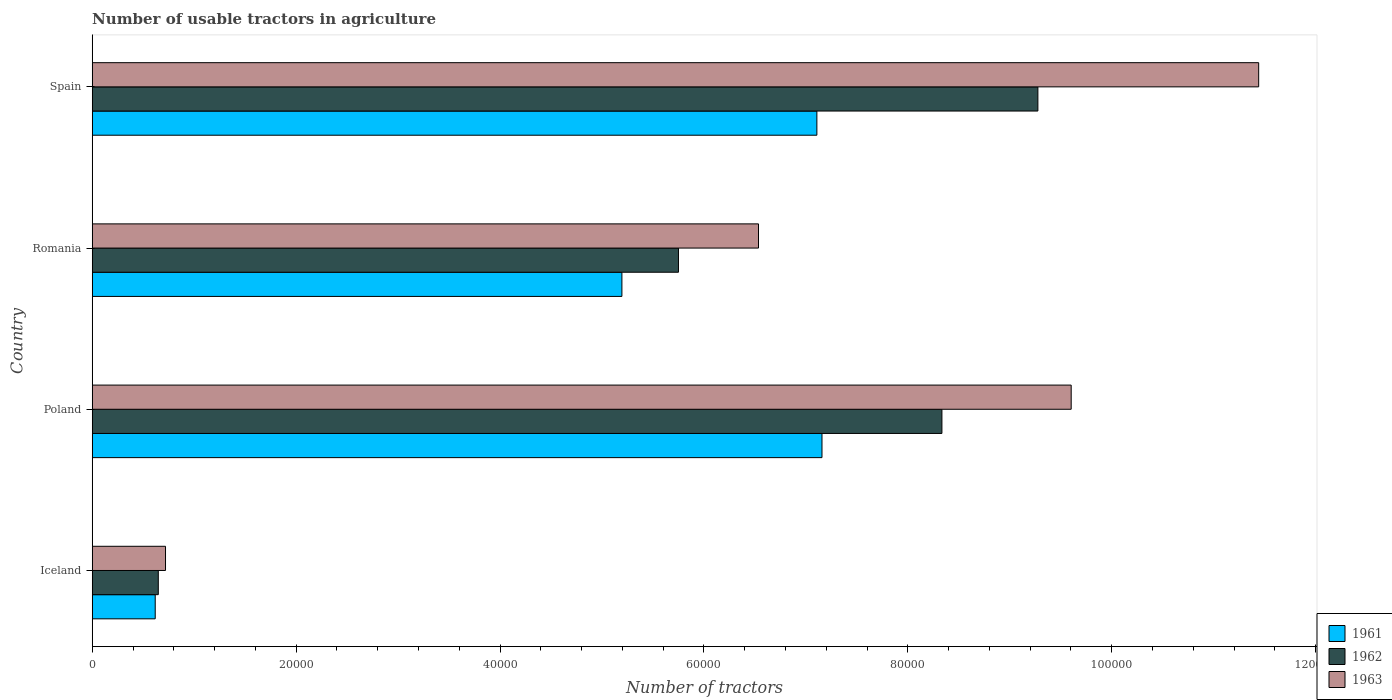What is the label of the 4th group of bars from the top?
Make the answer very short. Iceland. What is the number of usable tractors in agriculture in 1962 in Poland?
Your response must be concise. 8.33e+04. Across all countries, what is the maximum number of usable tractors in agriculture in 1962?
Ensure brevity in your answer.  9.28e+04. Across all countries, what is the minimum number of usable tractors in agriculture in 1962?
Keep it short and to the point. 6479. What is the total number of usable tractors in agriculture in 1963 in the graph?
Offer a very short reply. 2.83e+05. What is the difference between the number of usable tractors in agriculture in 1963 in Poland and that in Spain?
Your response must be concise. -1.84e+04. What is the difference between the number of usable tractors in agriculture in 1963 in Romania and the number of usable tractors in agriculture in 1962 in Spain?
Your answer should be very brief. -2.74e+04. What is the average number of usable tractors in agriculture in 1962 per country?
Make the answer very short. 6.00e+04. What is the difference between the number of usable tractors in agriculture in 1962 and number of usable tractors in agriculture in 1963 in Spain?
Keep it short and to the point. -2.17e+04. In how many countries, is the number of usable tractors in agriculture in 1961 greater than 116000 ?
Your response must be concise. 0. What is the ratio of the number of usable tractors in agriculture in 1961 in Poland to that in Spain?
Your response must be concise. 1.01. Is the number of usable tractors in agriculture in 1961 in Iceland less than that in Spain?
Provide a short and direct response. Yes. What is the difference between the highest and the lowest number of usable tractors in agriculture in 1962?
Your answer should be very brief. 8.63e+04. Is the sum of the number of usable tractors in agriculture in 1962 in Poland and Romania greater than the maximum number of usable tractors in agriculture in 1961 across all countries?
Provide a succinct answer. Yes. Is it the case that in every country, the sum of the number of usable tractors in agriculture in 1963 and number of usable tractors in agriculture in 1962 is greater than the number of usable tractors in agriculture in 1961?
Provide a short and direct response. Yes. Are all the bars in the graph horizontal?
Give a very brief answer. Yes. How many countries are there in the graph?
Offer a terse response. 4. What is the difference between two consecutive major ticks on the X-axis?
Keep it short and to the point. 2.00e+04. Where does the legend appear in the graph?
Ensure brevity in your answer.  Bottom right. How many legend labels are there?
Make the answer very short. 3. How are the legend labels stacked?
Your answer should be compact. Vertical. What is the title of the graph?
Provide a succinct answer. Number of usable tractors in agriculture. What is the label or title of the X-axis?
Provide a succinct answer. Number of tractors. What is the label or title of the Y-axis?
Provide a succinct answer. Country. What is the Number of tractors of 1961 in Iceland?
Ensure brevity in your answer.  6177. What is the Number of tractors of 1962 in Iceland?
Keep it short and to the point. 6479. What is the Number of tractors of 1963 in Iceland?
Your response must be concise. 7187. What is the Number of tractors in 1961 in Poland?
Keep it short and to the point. 7.16e+04. What is the Number of tractors in 1962 in Poland?
Make the answer very short. 8.33e+04. What is the Number of tractors of 1963 in Poland?
Provide a succinct answer. 9.60e+04. What is the Number of tractors in 1961 in Romania?
Keep it short and to the point. 5.20e+04. What is the Number of tractors in 1962 in Romania?
Offer a terse response. 5.75e+04. What is the Number of tractors of 1963 in Romania?
Provide a succinct answer. 6.54e+04. What is the Number of tractors in 1961 in Spain?
Your response must be concise. 7.11e+04. What is the Number of tractors of 1962 in Spain?
Keep it short and to the point. 9.28e+04. What is the Number of tractors in 1963 in Spain?
Give a very brief answer. 1.14e+05. Across all countries, what is the maximum Number of tractors of 1961?
Provide a succinct answer. 7.16e+04. Across all countries, what is the maximum Number of tractors of 1962?
Provide a short and direct response. 9.28e+04. Across all countries, what is the maximum Number of tractors in 1963?
Ensure brevity in your answer.  1.14e+05. Across all countries, what is the minimum Number of tractors in 1961?
Your answer should be very brief. 6177. Across all countries, what is the minimum Number of tractors in 1962?
Offer a terse response. 6479. Across all countries, what is the minimum Number of tractors of 1963?
Offer a terse response. 7187. What is the total Number of tractors of 1961 in the graph?
Your answer should be very brief. 2.01e+05. What is the total Number of tractors in 1962 in the graph?
Your response must be concise. 2.40e+05. What is the total Number of tractors in 1963 in the graph?
Offer a terse response. 2.83e+05. What is the difference between the Number of tractors in 1961 in Iceland and that in Poland?
Provide a short and direct response. -6.54e+04. What is the difference between the Number of tractors of 1962 in Iceland and that in Poland?
Your answer should be compact. -7.69e+04. What is the difference between the Number of tractors of 1963 in Iceland and that in Poland?
Your answer should be compact. -8.88e+04. What is the difference between the Number of tractors of 1961 in Iceland and that in Romania?
Your answer should be compact. -4.58e+04. What is the difference between the Number of tractors in 1962 in Iceland and that in Romania?
Ensure brevity in your answer.  -5.10e+04. What is the difference between the Number of tractors in 1963 in Iceland and that in Romania?
Make the answer very short. -5.82e+04. What is the difference between the Number of tractors in 1961 in Iceland and that in Spain?
Your answer should be compact. -6.49e+04. What is the difference between the Number of tractors of 1962 in Iceland and that in Spain?
Provide a succinct answer. -8.63e+04. What is the difference between the Number of tractors in 1963 in Iceland and that in Spain?
Offer a terse response. -1.07e+05. What is the difference between the Number of tractors in 1961 in Poland and that in Romania?
Ensure brevity in your answer.  1.96e+04. What is the difference between the Number of tractors in 1962 in Poland and that in Romania?
Ensure brevity in your answer.  2.58e+04. What is the difference between the Number of tractors in 1963 in Poland and that in Romania?
Ensure brevity in your answer.  3.07e+04. What is the difference between the Number of tractors in 1961 in Poland and that in Spain?
Offer a very short reply. 500. What is the difference between the Number of tractors in 1962 in Poland and that in Spain?
Your response must be concise. -9414. What is the difference between the Number of tractors of 1963 in Poland and that in Spain?
Provide a short and direct response. -1.84e+04. What is the difference between the Number of tractors of 1961 in Romania and that in Spain?
Provide a short and direct response. -1.91e+04. What is the difference between the Number of tractors of 1962 in Romania and that in Spain?
Provide a short and direct response. -3.53e+04. What is the difference between the Number of tractors in 1963 in Romania and that in Spain?
Offer a terse response. -4.91e+04. What is the difference between the Number of tractors of 1961 in Iceland and the Number of tractors of 1962 in Poland?
Your answer should be compact. -7.72e+04. What is the difference between the Number of tractors of 1961 in Iceland and the Number of tractors of 1963 in Poland?
Provide a succinct answer. -8.98e+04. What is the difference between the Number of tractors in 1962 in Iceland and the Number of tractors in 1963 in Poland?
Keep it short and to the point. -8.95e+04. What is the difference between the Number of tractors of 1961 in Iceland and the Number of tractors of 1962 in Romania?
Ensure brevity in your answer.  -5.13e+04. What is the difference between the Number of tractors of 1961 in Iceland and the Number of tractors of 1963 in Romania?
Make the answer very short. -5.92e+04. What is the difference between the Number of tractors of 1962 in Iceland and the Number of tractors of 1963 in Romania?
Your answer should be compact. -5.89e+04. What is the difference between the Number of tractors in 1961 in Iceland and the Number of tractors in 1962 in Spain?
Your answer should be compact. -8.66e+04. What is the difference between the Number of tractors in 1961 in Iceland and the Number of tractors in 1963 in Spain?
Ensure brevity in your answer.  -1.08e+05. What is the difference between the Number of tractors of 1962 in Iceland and the Number of tractors of 1963 in Spain?
Provide a succinct answer. -1.08e+05. What is the difference between the Number of tractors of 1961 in Poland and the Number of tractors of 1962 in Romania?
Provide a short and direct response. 1.41e+04. What is the difference between the Number of tractors of 1961 in Poland and the Number of tractors of 1963 in Romania?
Keep it short and to the point. 6226. What is the difference between the Number of tractors of 1962 in Poland and the Number of tractors of 1963 in Romania?
Provide a succinct answer. 1.80e+04. What is the difference between the Number of tractors of 1961 in Poland and the Number of tractors of 1962 in Spain?
Your response must be concise. -2.12e+04. What is the difference between the Number of tractors of 1961 in Poland and the Number of tractors of 1963 in Spain?
Your response must be concise. -4.28e+04. What is the difference between the Number of tractors in 1962 in Poland and the Number of tractors in 1963 in Spain?
Make the answer very short. -3.11e+04. What is the difference between the Number of tractors of 1961 in Romania and the Number of tractors of 1962 in Spain?
Provide a short and direct response. -4.08e+04. What is the difference between the Number of tractors in 1961 in Romania and the Number of tractors in 1963 in Spain?
Provide a succinct answer. -6.25e+04. What is the difference between the Number of tractors in 1962 in Romania and the Number of tractors in 1963 in Spain?
Your response must be concise. -5.69e+04. What is the average Number of tractors in 1961 per country?
Your answer should be very brief. 5.02e+04. What is the average Number of tractors of 1962 per country?
Provide a short and direct response. 6.00e+04. What is the average Number of tractors of 1963 per country?
Give a very brief answer. 7.07e+04. What is the difference between the Number of tractors in 1961 and Number of tractors in 1962 in Iceland?
Ensure brevity in your answer.  -302. What is the difference between the Number of tractors in 1961 and Number of tractors in 1963 in Iceland?
Ensure brevity in your answer.  -1010. What is the difference between the Number of tractors in 1962 and Number of tractors in 1963 in Iceland?
Keep it short and to the point. -708. What is the difference between the Number of tractors in 1961 and Number of tractors in 1962 in Poland?
Your answer should be very brief. -1.18e+04. What is the difference between the Number of tractors of 1961 and Number of tractors of 1963 in Poland?
Provide a short and direct response. -2.44e+04. What is the difference between the Number of tractors of 1962 and Number of tractors of 1963 in Poland?
Offer a very short reply. -1.27e+04. What is the difference between the Number of tractors of 1961 and Number of tractors of 1962 in Romania?
Provide a short and direct response. -5548. What is the difference between the Number of tractors of 1961 and Number of tractors of 1963 in Romania?
Provide a succinct answer. -1.34e+04. What is the difference between the Number of tractors of 1962 and Number of tractors of 1963 in Romania?
Give a very brief answer. -7851. What is the difference between the Number of tractors of 1961 and Number of tractors of 1962 in Spain?
Keep it short and to the point. -2.17e+04. What is the difference between the Number of tractors in 1961 and Number of tractors in 1963 in Spain?
Provide a short and direct response. -4.33e+04. What is the difference between the Number of tractors of 1962 and Number of tractors of 1963 in Spain?
Provide a short and direct response. -2.17e+04. What is the ratio of the Number of tractors in 1961 in Iceland to that in Poland?
Keep it short and to the point. 0.09. What is the ratio of the Number of tractors in 1962 in Iceland to that in Poland?
Give a very brief answer. 0.08. What is the ratio of the Number of tractors in 1963 in Iceland to that in Poland?
Provide a succinct answer. 0.07. What is the ratio of the Number of tractors of 1961 in Iceland to that in Romania?
Provide a succinct answer. 0.12. What is the ratio of the Number of tractors in 1962 in Iceland to that in Romania?
Offer a terse response. 0.11. What is the ratio of the Number of tractors in 1963 in Iceland to that in Romania?
Offer a very short reply. 0.11. What is the ratio of the Number of tractors in 1961 in Iceland to that in Spain?
Give a very brief answer. 0.09. What is the ratio of the Number of tractors of 1962 in Iceland to that in Spain?
Give a very brief answer. 0.07. What is the ratio of the Number of tractors of 1963 in Iceland to that in Spain?
Offer a very short reply. 0.06. What is the ratio of the Number of tractors of 1961 in Poland to that in Romania?
Offer a terse response. 1.38. What is the ratio of the Number of tractors of 1962 in Poland to that in Romania?
Your response must be concise. 1.45. What is the ratio of the Number of tractors in 1963 in Poland to that in Romania?
Your answer should be compact. 1.47. What is the ratio of the Number of tractors of 1961 in Poland to that in Spain?
Provide a short and direct response. 1.01. What is the ratio of the Number of tractors in 1962 in Poland to that in Spain?
Offer a terse response. 0.9. What is the ratio of the Number of tractors of 1963 in Poland to that in Spain?
Provide a succinct answer. 0.84. What is the ratio of the Number of tractors of 1961 in Romania to that in Spain?
Offer a terse response. 0.73. What is the ratio of the Number of tractors of 1962 in Romania to that in Spain?
Keep it short and to the point. 0.62. What is the ratio of the Number of tractors of 1963 in Romania to that in Spain?
Offer a very short reply. 0.57. What is the difference between the highest and the second highest Number of tractors in 1962?
Offer a very short reply. 9414. What is the difference between the highest and the second highest Number of tractors of 1963?
Offer a very short reply. 1.84e+04. What is the difference between the highest and the lowest Number of tractors in 1961?
Offer a terse response. 6.54e+04. What is the difference between the highest and the lowest Number of tractors of 1962?
Your response must be concise. 8.63e+04. What is the difference between the highest and the lowest Number of tractors in 1963?
Provide a short and direct response. 1.07e+05. 